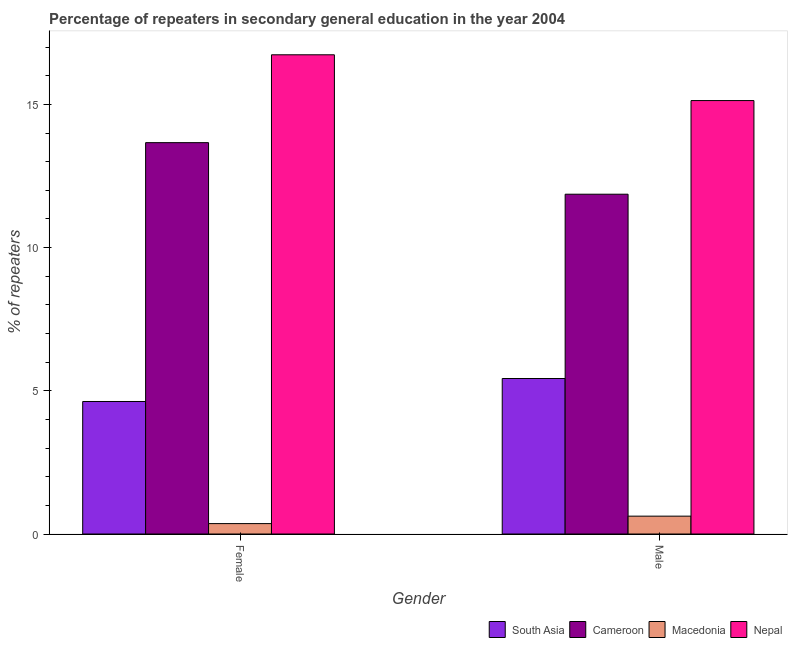How many groups of bars are there?
Make the answer very short. 2. Are the number of bars on each tick of the X-axis equal?
Provide a short and direct response. Yes. How many bars are there on the 2nd tick from the right?
Provide a succinct answer. 4. What is the percentage of female repeaters in South Asia?
Give a very brief answer. 4.63. Across all countries, what is the maximum percentage of female repeaters?
Provide a succinct answer. 16.73. Across all countries, what is the minimum percentage of female repeaters?
Provide a succinct answer. 0.36. In which country was the percentage of male repeaters maximum?
Provide a short and direct response. Nepal. In which country was the percentage of female repeaters minimum?
Offer a very short reply. Macedonia. What is the total percentage of male repeaters in the graph?
Offer a terse response. 33.05. What is the difference between the percentage of female repeaters in Nepal and that in South Asia?
Keep it short and to the point. 12.1. What is the difference between the percentage of female repeaters in Cameroon and the percentage of male repeaters in Nepal?
Offer a very short reply. -1.47. What is the average percentage of female repeaters per country?
Provide a succinct answer. 8.85. What is the difference between the percentage of male repeaters and percentage of female repeaters in Macedonia?
Your response must be concise. 0.26. What is the ratio of the percentage of female repeaters in Cameroon to that in Macedonia?
Provide a short and direct response. 37.6. In how many countries, is the percentage of male repeaters greater than the average percentage of male repeaters taken over all countries?
Give a very brief answer. 2. What does the 3rd bar from the left in Female represents?
Your answer should be compact. Macedonia. What does the 2nd bar from the right in Male represents?
Give a very brief answer. Macedonia. How many bars are there?
Provide a succinct answer. 8. How many countries are there in the graph?
Your response must be concise. 4. What is the difference between two consecutive major ticks on the Y-axis?
Provide a short and direct response. 5. Are the values on the major ticks of Y-axis written in scientific E-notation?
Give a very brief answer. No. Does the graph contain grids?
Provide a succinct answer. No. What is the title of the graph?
Provide a succinct answer. Percentage of repeaters in secondary general education in the year 2004. Does "Iran" appear as one of the legend labels in the graph?
Give a very brief answer. No. What is the label or title of the Y-axis?
Offer a very short reply. % of repeaters. What is the % of repeaters in South Asia in Female?
Your answer should be very brief. 4.63. What is the % of repeaters in Cameroon in Female?
Make the answer very short. 13.66. What is the % of repeaters of Macedonia in Female?
Offer a very short reply. 0.36. What is the % of repeaters of Nepal in Female?
Offer a terse response. 16.73. What is the % of repeaters of South Asia in Male?
Provide a succinct answer. 5.43. What is the % of repeaters of Cameroon in Male?
Give a very brief answer. 11.86. What is the % of repeaters of Macedonia in Male?
Your answer should be compact. 0.62. What is the % of repeaters of Nepal in Male?
Your answer should be compact. 15.13. Across all Gender, what is the maximum % of repeaters of South Asia?
Offer a very short reply. 5.43. Across all Gender, what is the maximum % of repeaters in Cameroon?
Make the answer very short. 13.66. Across all Gender, what is the maximum % of repeaters in Macedonia?
Provide a short and direct response. 0.62. Across all Gender, what is the maximum % of repeaters in Nepal?
Give a very brief answer. 16.73. Across all Gender, what is the minimum % of repeaters of South Asia?
Provide a short and direct response. 4.63. Across all Gender, what is the minimum % of repeaters of Cameroon?
Your response must be concise. 11.86. Across all Gender, what is the minimum % of repeaters in Macedonia?
Keep it short and to the point. 0.36. Across all Gender, what is the minimum % of repeaters of Nepal?
Offer a terse response. 15.13. What is the total % of repeaters of South Asia in the graph?
Offer a very short reply. 10.06. What is the total % of repeaters of Cameroon in the graph?
Ensure brevity in your answer.  25.53. What is the total % of repeaters of Macedonia in the graph?
Ensure brevity in your answer.  0.99. What is the total % of repeaters of Nepal in the graph?
Offer a terse response. 31.86. What is the difference between the % of repeaters in South Asia in Female and that in Male?
Make the answer very short. -0.8. What is the difference between the % of repeaters in Cameroon in Female and that in Male?
Keep it short and to the point. 1.8. What is the difference between the % of repeaters of Macedonia in Female and that in Male?
Provide a short and direct response. -0.26. What is the difference between the % of repeaters of Nepal in Female and that in Male?
Give a very brief answer. 1.6. What is the difference between the % of repeaters in South Asia in Female and the % of repeaters in Cameroon in Male?
Provide a succinct answer. -7.24. What is the difference between the % of repeaters of South Asia in Female and the % of repeaters of Macedonia in Male?
Give a very brief answer. 4. What is the difference between the % of repeaters of South Asia in Female and the % of repeaters of Nepal in Male?
Offer a very short reply. -10.51. What is the difference between the % of repeaters in Cameroon in Female and the % of repeaters in Macedonia in Male?
Offer a very short reply. 13.04. What is the difference between the % of repeaters of Cameroon in Female and the % of repeaters of Nepal in Male?
Offer a very short reply. -1.47. What is the difference between the % of repeaters in Macedonia in Female and the % of repeaters in Nepal in Male?
Keep it short and to the point. -14.77. What is the average % of repeaters in South Asia per Gender?
Give a very brief answer. 5.03. What is the average % of repeaters of Cameroon per Gender?
Make the answer very short. 12.76. What is the average % of repeaters of Macedonia per Gender?
Your response must be concise. 0.49. What is the average % of repeaters of Nepal per Gender?
Keep it short and to the point. 15.93. What is the difference between the % of repeaters in South Asia and % of repeaters in Cameroon in Female?
Keep it short and to the point. -9.04. What is the difference between the % of repeaters in South Asia and % of repeaters in Macedonia in Female?
Ensure brevity in your answer.  4.26. What is the difference between the % of repeaters in South Asia and % of repeaters in Nepal in Female?
Provide a short and direct response. -12.11. What is the difference between the % of repeaters in Cameroon and % of repeaters in Macedonia in Female?
Give a very brief answer. 13.3. What is the difference between the % of repeaters in Cameroon and % of repeaters in Nepal in Female?
Make the answer very short. -3.07. What is the difference between the % of repeaters in Macedonia and % of repeaters in Nepal in Female?
Provide a succinct answer. -16.37. What is the difference between the % of repeaters in South Asia and % of repeaters in Cameroon in Male?
Offer a terse response. -6.43. What is the difference between the % of repeaters in South Asia and % of repeaters in Macedonia in Male?
Ensure brevity in your answer.  4.81. What is the difference between the % of repeaters of South Asia and % of repeaters of Nepal in Male?
Offer a terse response. -9.7. What is the difference between the % of repeaters in Cameroon and % of repeaters in Macedonia in Male?
Provide a short and direct response. 11.24. What is the difference between the % of repeaters of Cameroon and % of repeaters of Nepal in Male?
Ensure brevity in your answer.  -3.27. What is the difference between the % of repeaters of Macedonia and % of repeaters of Nepal in Male?
Provide a short and direct response. -14.51. What is the ratio of the % of repeaters of South Asia in Female to that in Male?
Provide a short and direct response. 0.85. What is the ratio of the % of repeaters in Cameroon in Female to that in Male?
Provide a succinct answer. 1.15. What is the ratio of the % of repeaters in Macedonia in Female to that in Male?
Your answer should be very brief. 0.58. What is the ratio of the % of repeaters in Nepal in Female to that in Male?
Your answer should be very brief. 1.11. What is the difference between the highest and the second highest % of repeaters in South Asia?
Provide a short and direct response. 0.8. What is the difference between the highest and the second highest % of repeaters of Cameroon?
Provide a succinct answer. 1.8. What is the difference between the highest and the second highest % of repeaters in Macedonia?
Provide a short and direct response. 0.26. What is the difference between the highest and the second highest % of repeaters of Nepal?
Offer a very short reply. 1.6. What is the difference between the highest and the lowest % of repeaters of South Asia?
Your response must be concise. 0.8. What is the difference between the highest and the lowest % of repeaters in Cameroon?
Give a very brief answer. 1.8. What is the difference between the highest and the lowest % of repeaters in Macedonia?
Offer a very short reply. 0.26. What is the difference between the highest and the lowest % of repeaters in Nepal?
Make the answer very short. 1.6. 